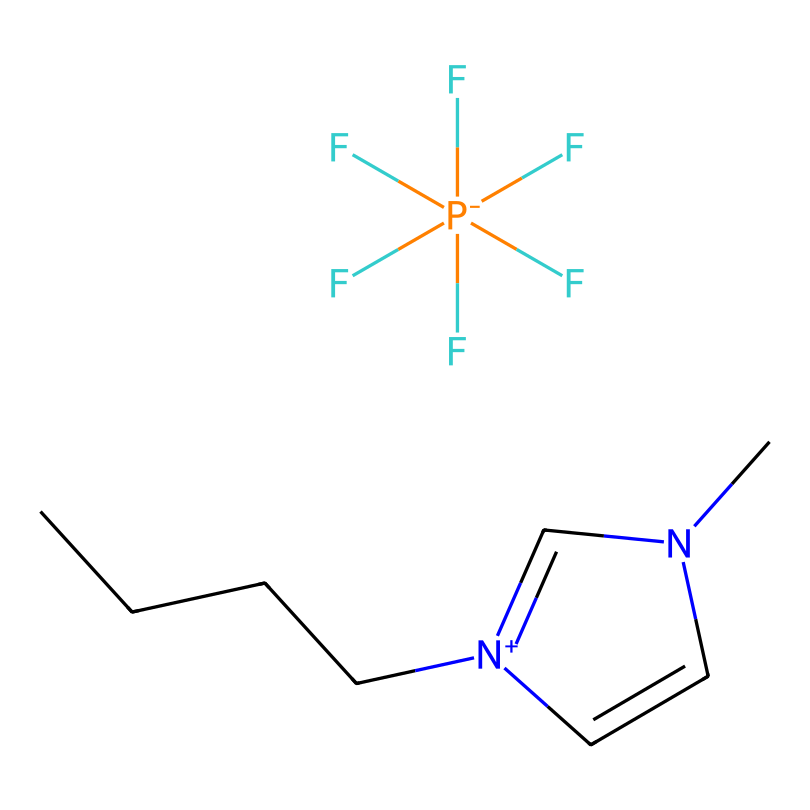What is the cation in this ionic liquid? The cation is determined by identifying the positively charged portion of the molecule. In this structure, the portion that contains nitrogen and carbon chains (1-butyl-3-methylimidazolium) indicates that it is the cation.
Answer: 1-butyl-3-methylimidazolium How many fluorine atoms are present in this ionic liquid? By examining the structure, we observe that there are five fluorine atoms attached to the hexafluorophosphate anion (F[P-](F)(F)(F)(F)F), hence counting them gives us five.
Answer: 5 What charge does the hexafluorophosphate anion have? The presence of the phosphorus atom surrounded by five fluorine atoms in the structure indicates that the anion has a negative charge, denoted by [P-].
Answer: -1 What functional group can be identified in this ionic liquid? The imidazolium ring structure, which includes nitrogen atoms, identifies it as part of the functional group present in this ionic liquid.
Answer: Imidazolium What is the total number of carbon atoms in the cation of this ionic liquid? The cation 1-butyl-3-methylimidazolium has a butyl group (4 carbon atoms) and a methyl group (1 carbon atom), along with two from the imidazolium ring, totaling to seven carbons.
Answer: 7 Is this ionic liquid considered hydrophilic or hydrophobic? The long hydrocarbon chain (butyl group) suggests that the ionic liquid is hydrophobic; thus, it has a tendency to repel water.
Answer: Hydrophobic What are the key applications of this ionic liquid? The structure indicates its use in applications like conductive inks for touchscreens, due to its ionic conductivity and stability.
Answer: Conductive inks 